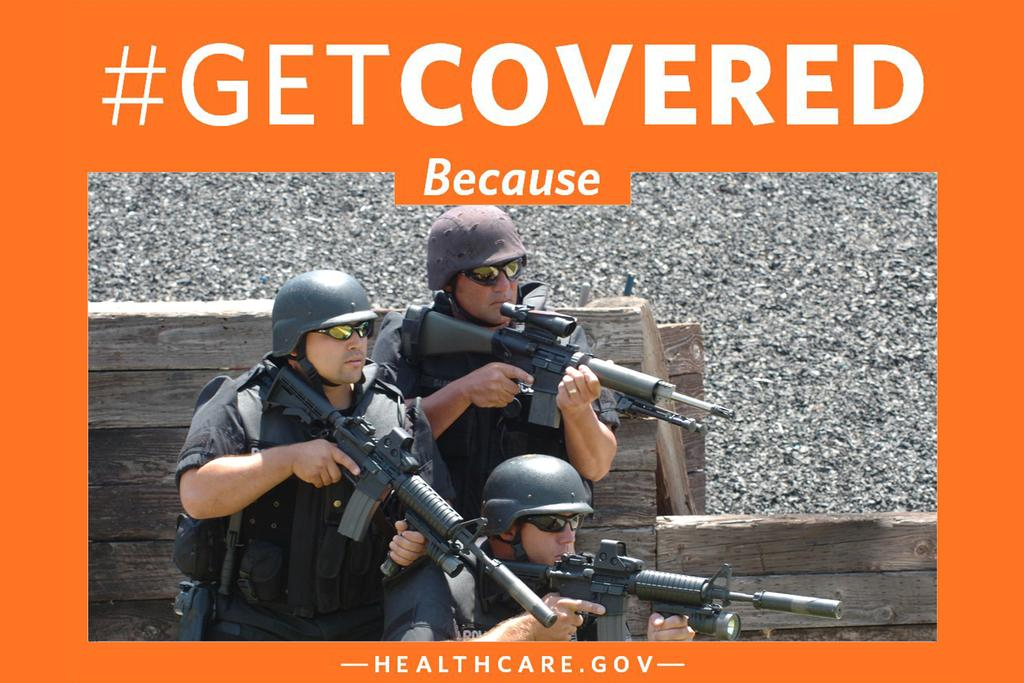How many people are in the image? There are three people in the image. What are the people holding in the image? Each person is holding a gun in the image. What protective gear are the people wearing in the image? Each person is wearing a helmet in the image. What type of porter is carrying a load in the image? There is no porter carrying a load in the image; the focus is on the three people holding guns and wearing helmets. 